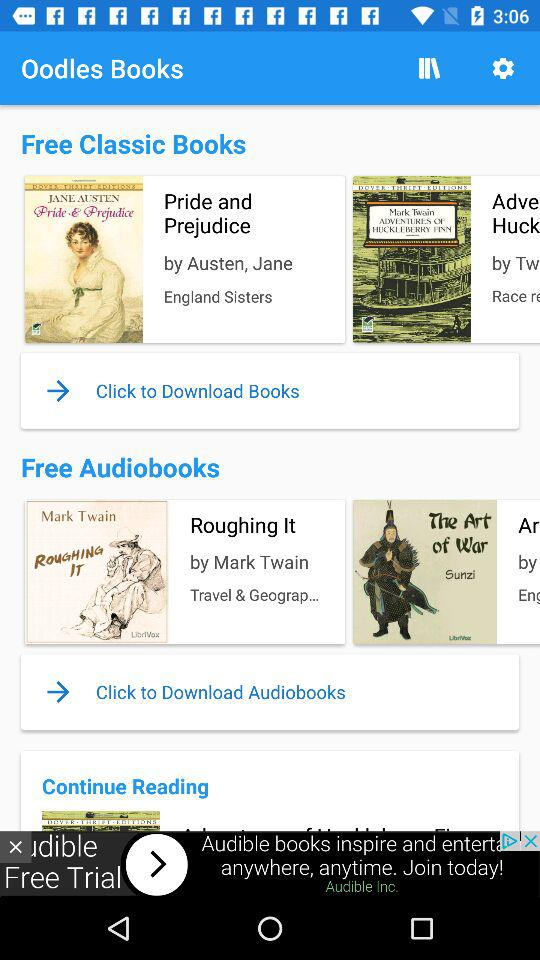Who is the author of the book "Pride and Prejudice"? The author of the book "Pride and Prejudice" is Jane Austen. 